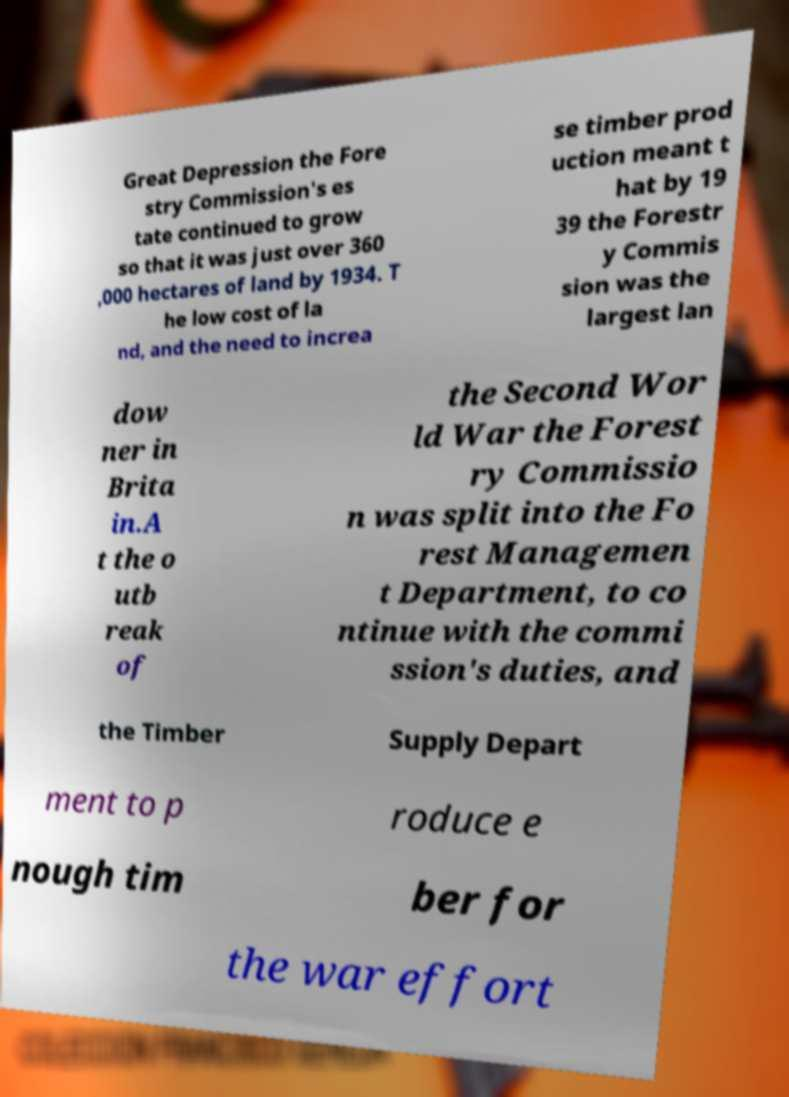Please read and relay the text visible in this image. What does it say? Great Depression the Fore stry Commission's es tate continued to grow so that it was just over 360 ,000 hectares of land by 1934. T he low cost of la nd, and the need to increa se timber prod uction meant t hat by 19 39 the Forestr y Commis sion was the largest lan dow ner in Brita in.A t the o utb reak of the Second Wor ld War the Forest ry Commissio n was split into the Fo rest Managemen t Department, to co ntinue with the commi ssion's duties, and the Timber Supply Depart ment to p roduce e nough tim ber for the war effort 